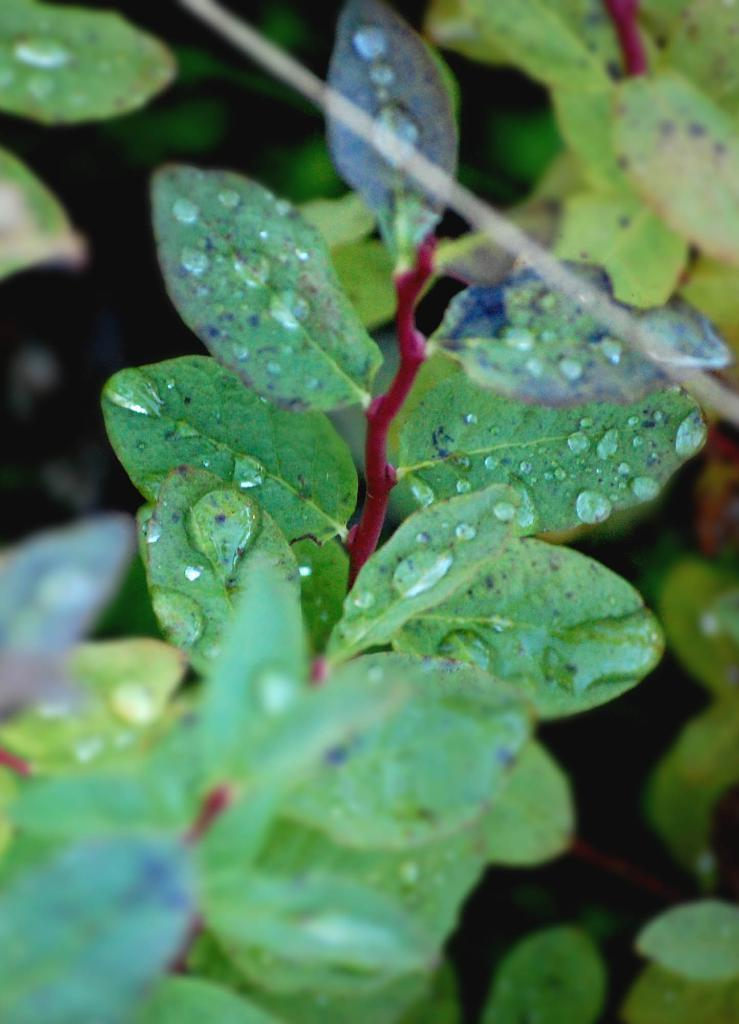What is present in the image? There is a tree in the image. What colors can be seen on the tree? The tree has red and green colors. Can you describe the condition of the tree's leaves? There are water drops on the leaves of the tree. What type of fiction is being read by the tree in the image? There is no fiction or reading activity present in the image; it features a tree with red and green colors and water drops on its leaves. 